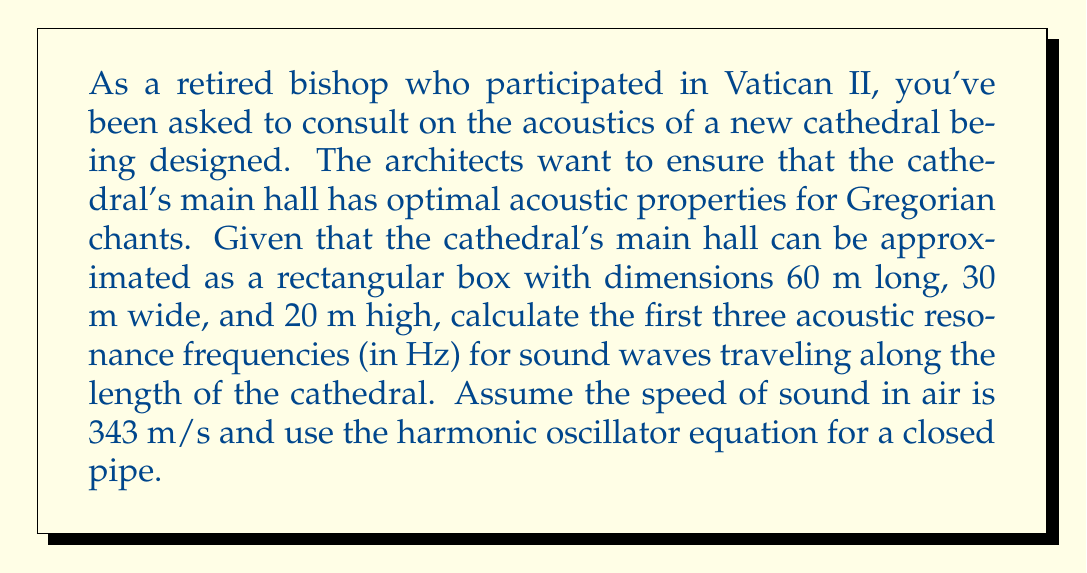Give your solution to this math problem. To solve this problem, we'll use the harmonic oscillator equation for a closed pipe, which is analogous to the situation in the cathedral. The equation for the resonant frequencies in a closed pipe is:

$$f_n = \frac{nv}{2L}$$

Where:
$f_n$ is the nth resonant frequency
$n$ is the harmonic number (1, 2, 3, ...)
$v$ is the speed of sound in air
$L$ is the length of the pipe (in this case, the length of the cathedral)

Given:
- Length of the cathedral (L) = 60 m
- Speed of sound in air (v) = 343 m/s

Let's calculate the first three resonant frequencies:

1. For n = 1 (fundamental frequency):
   $$f_1 = \frac{1 \cdot 343}{2 \cdot 60} = \frac{343}{120} = 2.8583 \text{ Hz}$$

2. For n = 2 (second harmonic):
   $$f_2 = \frac{2 \cdot 343}{2 \cdot 60} = \frac{686}{120} = 5.7167 \text{ Hz}$$

3. For n = 3 (third harmonic):
   $$f_3 = \frac{3 \cdot 343}{2 \cdot 60} = \frac{1029}{120} = 8.5750 \text{ Hz}$$

These frequencies represent the first three acoustic resonance modes along the length of the cathedral. They are important for understanding how sound will behave in the space, particularly for Gregorian chants which often have rich harmonic content.
Answer: The first three acoustic resonance frequencies for sound waves traveling along the length of the cathedral are:

1. $f_1 = 2.86 \text{ Hz}$
2. $f_2 = 5.72 \text{ Hz}$
3. $f_3 = 8.58 \text{ Hz}$

(rounded to two decimal places) 